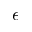Convert formula to latex. <formula><loc_0><loc_0><loc_500><loc_500>\epsilon</formula> 